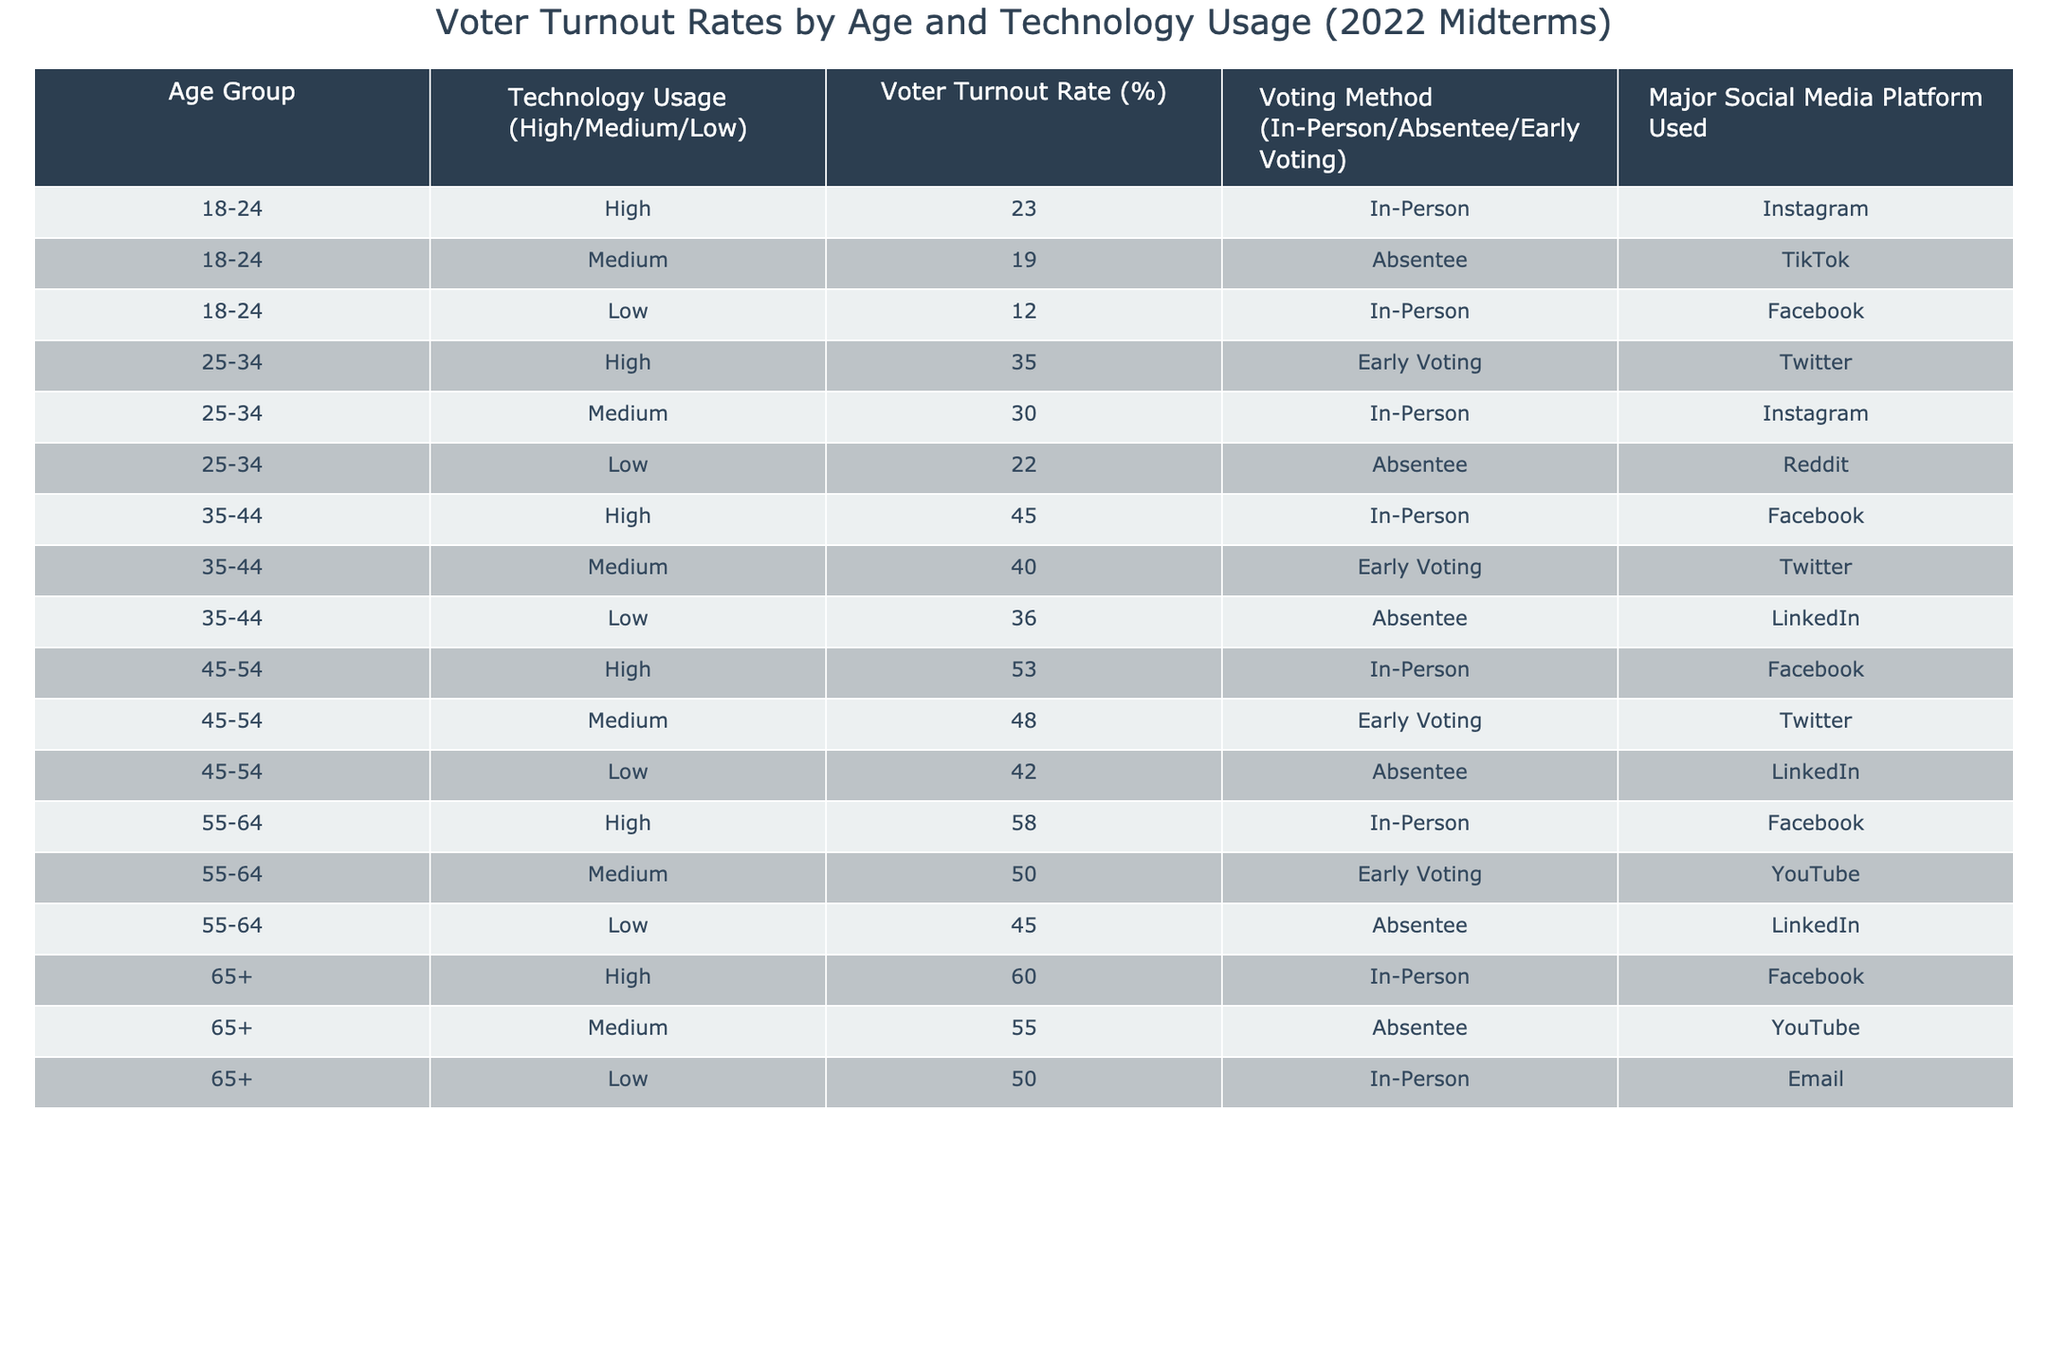What is the voter turnout rate for the 25-34 age group with high technology usage? From the table, we look at the row for the 25-34 age group with high technology usage, which shows a voter turnout rate of 35%.
Answer: 35% Which age group has the highest voter turnout rate? By examining the voter turnout rates for all age groups, we find that the 55-64 age group has the highest rate at 58%.
Answer: 55-64 How does the voter turnout rate for the 65+ age group compare to the 18-24 age group with low technology usage? The voter turnout rate for the 65+ age group is 60%, while the 18-24 age group with low technology usage has a turnout rate of 12%. The difference is 60 - 12 = 48%.
Answer: 48% What is the average voter turnout rate for all age groups with medium technology usage? The voter turnout rates for medium technology usage are 19, 30, 40, 48, 50, and 55. The sum is 19 + 30 + 40 + 48 + 50 + 55 = 242. There are 6 values, so the average is 242 / 6 = 40.33.
Answer: 40.33 True or False: The majority of 35-44 year-olds voted absentee when their technology usage was low. Checking the 35-44 age group's data for low technology usage reveals a turnout method of absentee voting, but the column does not indicate a majority as only one row exists.
Answer: True What voting method had the lowest turnout rate among the 18-24 age group? For the 18-24 age group, the in-person turnout rate is 23%, absentee is 19%, and low technology is 12%. The lowest turnout rate is for the low technology usage at 12%, which is associated with in-person voting.
Answer: 12% By how much does the voter turnout rate for the 45-54 age group with low technology usage exceed that of the 18-24 age group with high technology usage? The voter turnout rate for the 45-54 age group with low technology usage is 42%. The turnout rate for the 18-24 age group with high technology usage is 23%. The difference is 42 - 23 = 19%.
Answer: 19% What is the total voter turnout rate for all age groups that participated using early voting? The turnout rates for early voting are 35 (for 25-34), 40 (for 35-44), and 50 (for 55-64). Adding these gives us 35 + 40 + 50 = 125.
Answer: 125 Which major social media platform was most frequently used by the 55-64 age group? In reviewing the data for the 55-64 age group, it appears that Facebook was used in the high technology usage category, while YouTube was used in the medium and LinkedIn in the low category, with Facebook being mentioned twice.
Answer: Facebook How does the voting method distribution differ between the 45-54 and 55-64 age groups for those with medium technology usage? In the 45-54 age group, the medium technology usage shows early voting, while in the 55-64 age group, it is for early voting as well. There is no difference in voting methods but a difference in turnout rates (48% vs 50%).
Answer: No difference in method, turnout rates differ 